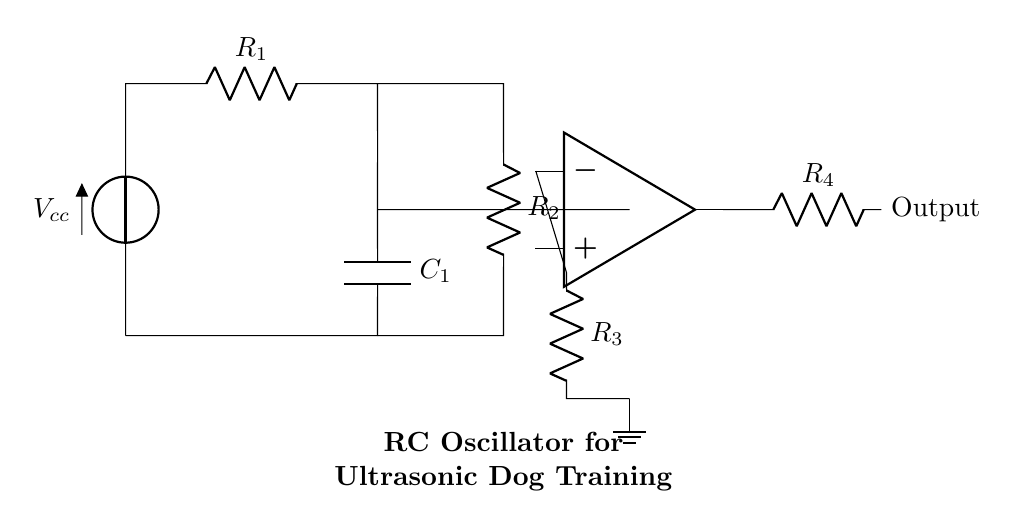What is the power supply voltage of this circuit? The power supply voltage, denoted as Vcc in the circuit diagram, is the voltage provided to the circuit. It is crucial as it powers all the components.
Answer: Vcc What type of capacitor is used in this circuit? The capacitor shown in the circuit is labeled as C1, which is a capacitor specific to the RC oscillator configuration. Capacitors in oscillator circuits are typically used for timing and frequency generation.
Answer: C1 What is the purpose of the resistor R1 in this circuit? Resistor R1, connected in series with the voltage supply, helps to limit the current flowing into the capacitor C1 and affects the charging time. This influences the frequency of oscillation in the circuit.
Answer: Current limiting Which component determines the oscillation frequency in this RC oscillator? The oscillation frequency in an RC oscillator is determined by the resistor-capacitor combination (R1, R2, and C1) as they define the time constant of the circuit, which directly influences the rate of oscillation.
Answer: R1, R2, C1 How many resistors are in the circuit? The circuit diagram shows a total of four resistors (R1, R2, R3, and R4). Each influences the circuit's behavior and operation in different ways.
Answer: Four What is the function of the op-amp in this circuit? The operational amplifier (op-amp) in the circuit acts as a comparator and amplifier, generating the necessary signal shape for oscillation and boosting the output signal to drive connected components, such as speakers.
Answer: Signal generation Where is the output of this circuit taken from? The output of this RC oscillator circuit is taken from the node connected to R4, which is the component at the right side of the op-amp's output. This is where the generated signal is provided for use, such as for driving a sound emitter.
Answer: From R4 